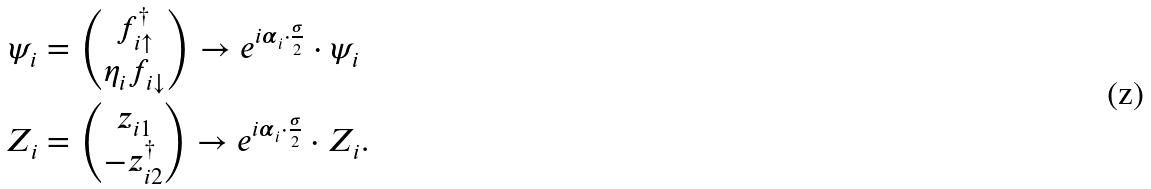<formula> <loc_0><loc_0><loc_500><loc_500>\psi _ { i } & = \begin{pmatrix} f _ { i \uparrow } ^ { \dagger } \\ \eta _ { i } f _ { i \downarrow } \end{pmatrix} \rightarrow e ^ { i \boldsymbol \alpha _ { i } \cdot \frac { \boldsymbol \sigma } { 2 } } \cdot \psi _ { i } \\ Z _ { i } & = \begin{pmatrix} z _ { i 1 } \\ - z _ { i 2 } ^ { \dagger } \end{pmatrix} \rightarrow e ^ { i \boldsymbol \alpha _ { i } \cdot \frac { \boldsymbol \sigma } { 2 } } \cdot Z _ { i } .</formula> 